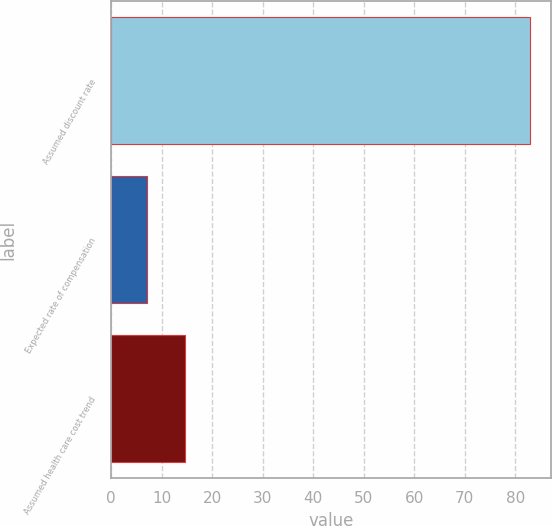Convert chart. <chart><loc_0><loc_0><loc_500><loc_500><bar_chart><fcel>Assumed discount rate<fcel>Expected rate of compensation<fcel>Assumed health care cost trend<nl><fcel>83<fcel>7<fcel>14.6<nl></chart> 